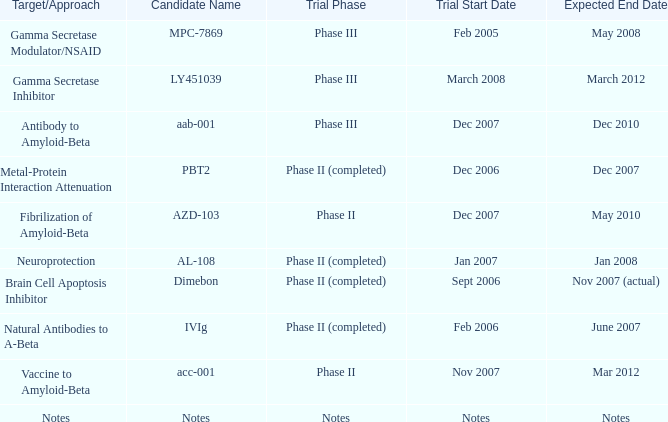When the target/approach is notes, what is the anticipated completion date? Notes. 